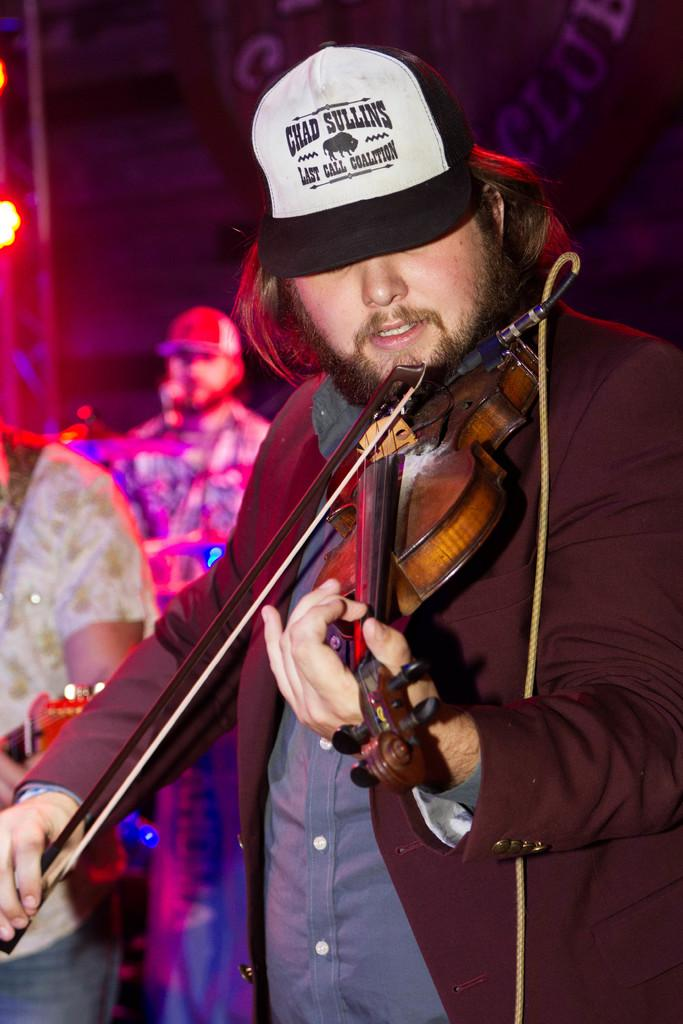What is the person in the image wearing? The person in the image is wearing a black suit. What is the person doing in the image? The person is playing the violin. Are there any other people visible in the image? Yes, there are other people behind the person playing the violin. What type of dog can be seen playing with a pail in the image? There is no dog or pail present in the image; it features a person playing the violin. How does the person playing the violin show respect to the audience in the image? The image does not provide information about the person's actions or intentions towards the audience, so it cannot be determined how they show respect. 